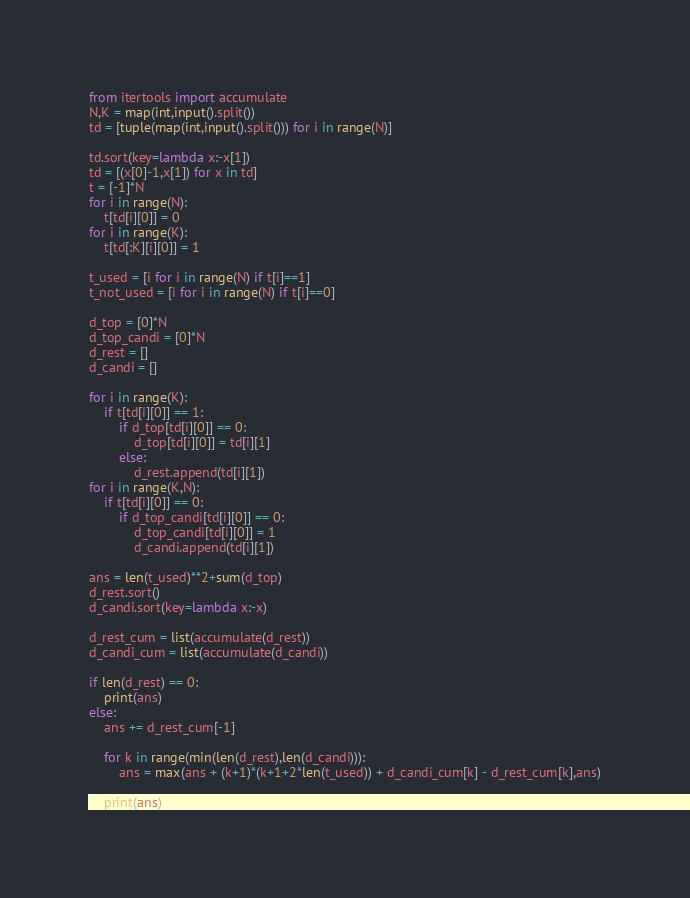<code> <loc_0><loc_0><loc_500><loc_500><_Python_>from itertools import accumulate
N,K = map(int,input().split())
td = [tuple(map(int,input().split())) for i in range(N)]

td.sort(key=lambda x:-x[1])
td = [(x[0]-1,x[1]) for x in td]
t = [-1]*N
for i in range(N):
    t[td[i][0]] = 0
for i in range(K):
    t[td[:K][i][0]] = 1

t_used = [i for i in range(N) if t[i]==1]
t_not_used = [i for i in range(N) if t[i]==0]

d_top = [0]*N
d_top_candi = [0]*N
d_rest = []
d_candi = []

for i in range(K):
    if t[td[i][0]] == 1:
        if d_top[td[i][0]] == 0:
            d_top[td[i][0]] = td[i][1]
        else:
            d_rest.append(td[i][1])
for i in range(K,N):
    if t[td[i][0]] == 0:
        if d_top_candi[td[i][0]] == 0:
            d_top_candi[td[i][0]] = 1
            d_candi.append(td[i][1])

ans = len(t_used)**2+sum(d_top)
d_rest.sort()
d_candi.sort(key=lambda x:-x)

d_rest_cum = list(accumulate(d_rest))
d_candi_cum = list(accumulate(d_candi))

if len(d_rest) == 0:
    print(ans)
else:
    ans += d_rest_cum[-1]

    for k in range(min(len(d_rest),len(d_candi))):
        ans = max(ans + (k+1)*(k+1+2*len(t_used)) + d_candi_cum[k] - d_rest_cum[k],ans)

    print(ans)</code> 